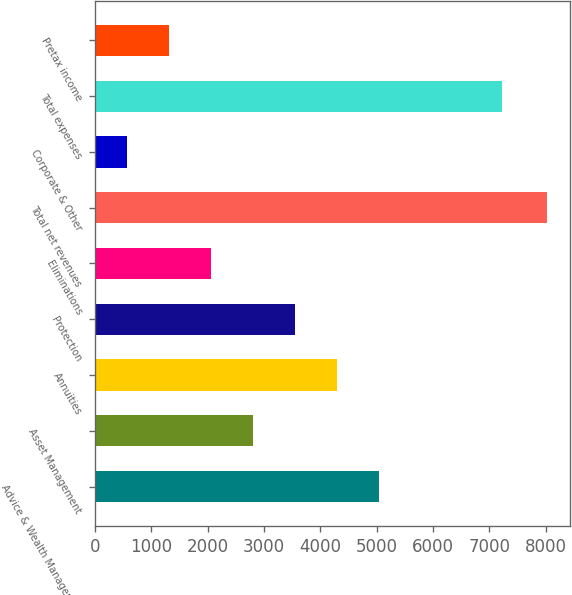<chart> <loc_0><loc_0><loc_500><loc_500><bar_chart><fcel>Advice & Wealth Management<fcel>Asset Management<fcel>Annuities<fcel>Protection<fcel>Eliminations<fcel>Total net revenues<fcel>Corporate & Other<fcel>Total expenses<fcel>Pretax income<nl><fcel>5046.8<fcel>2812.4<fcel>4302<fcel>3557.2<fcel>2067.6<fcel>8026<fcel>578<fcel>7229<fcel>1322.8<nl></chart> 